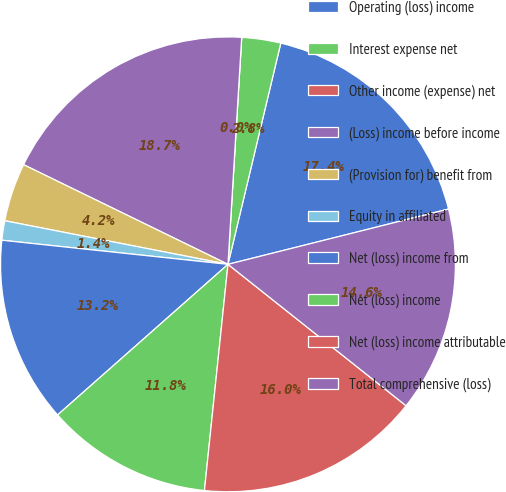Convert chart to OTSL. <chart><loc_0><loc_0><loc_500><loc_500><pie_chart><fcel>Operating (loss) income<fcel>Interest expense net<fcel>Other income (expense) net<fcel>(Loss) income before income<fcel>(Provision for) benefit from<fcel>Equity in affiliated<fcel>Net (loss) income from<fcel>Net (loss) income<fcel>Net (loss) income attributable<fcel>Total comprehensive (loss)<nl><fcel>17.36%<fcel>2.77%<fcel>0.0%<fcel>18.74%<fcel>4.15%<fcel>1.38%<fcel>13.21%<fcel>11.83%<fcel>15.97%<fcel>14.59%<nl></chart> 